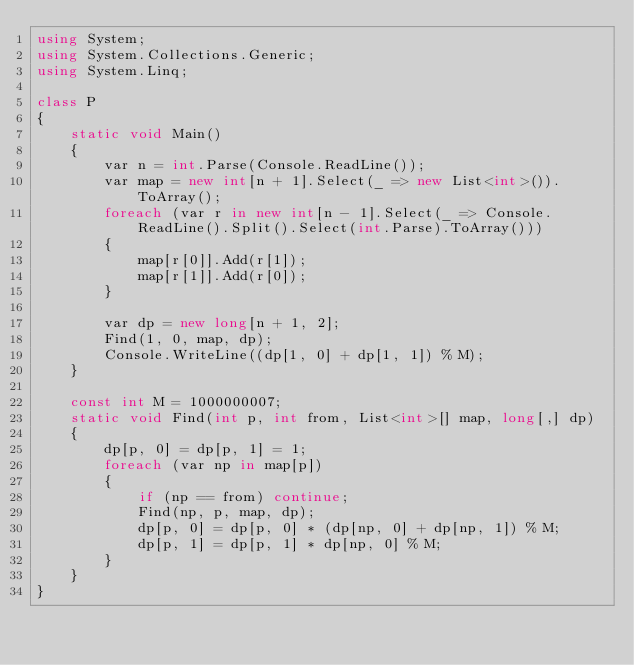Convert code to text. <code><loc_0><loc_0><loc_500><loc_500><_C#_>using System;
using System.Collections.Generic;
using System.Linq;

class P
{
	static void Main()
	{
		var n = int.Parse(Console.ReadLine());
		var map = new int[n + 1].Select(_ => new List<int>()).ToArray();
		foreach (var r in new int[n - 1].Select(_ => Console.ReadLine().Split().Select(int.Parse).ToArray()))
		{
			map[r[0]].Add(r[1]);
			map[r[1]].Add(r[0]);
		}

		var dp = new long[n + 1, 2];
		Find(1, 0, map, dp);
		Console.WriteLine((dp[1, 0] + dp[1, 1]) % M);
	}

	const int M = 1000000007;
	static void Find(int p, int from, List<int>[] map, long[,] dp)
	{
		dp[p, 0] = dp[p, 1] = 1;
		foreach (var np in map[p])
		{
			if (np == from) continue;
			Find(np, p, map, dp);
			dp[p, 0] = dp[p, 0] * (dp[np, 0] + dp[np, 1]) % M;
			dp[p, 1] = dp[p, 1] * dp[np, 0] % M;
		}
	}
}
</code> 